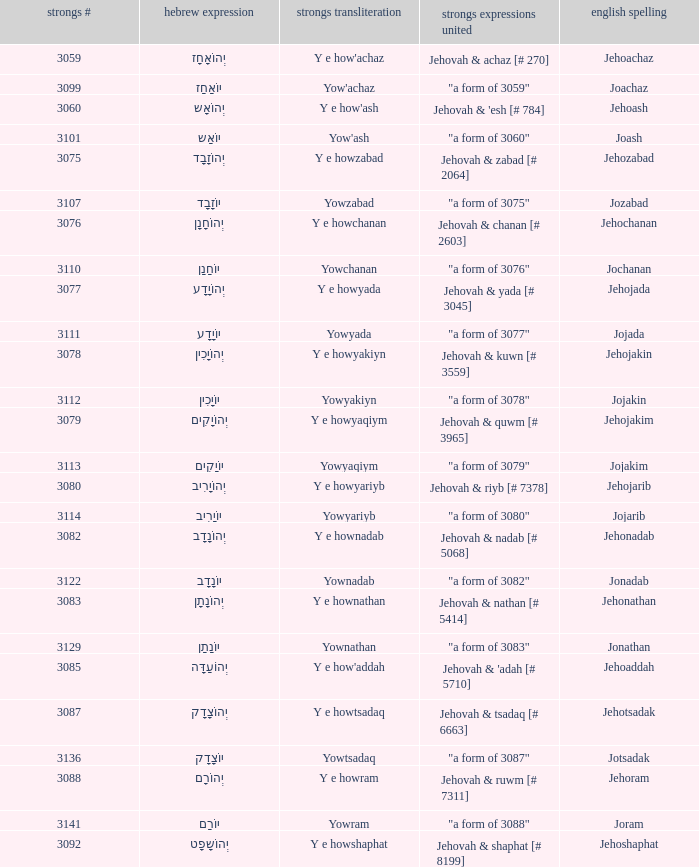What is the strongs # of the english spelling word jehojakin? 3078.0. 